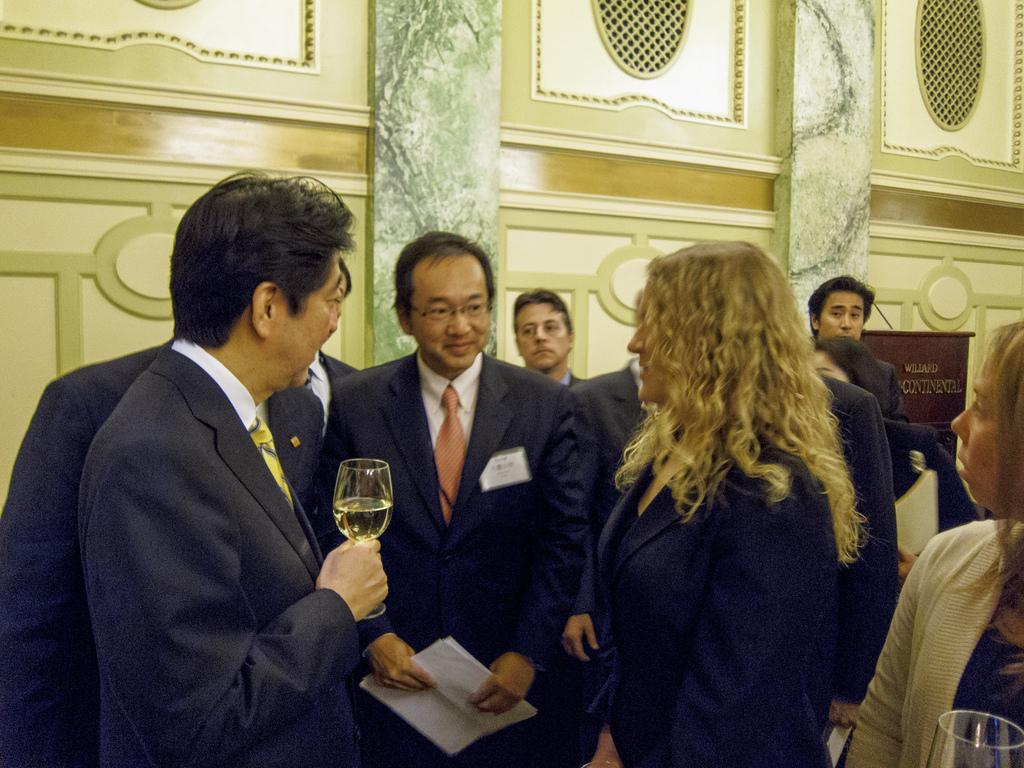How many people are in the image? There is a group of people in the image. What are some of the people holding? Some of the people are holding glasses. What is the man holding in the image? One man is holding papers. What can be seen in the background of the image? There is a wall in the background of the image. What type of spot can be seen on the authority figure in the image? There is no authority figure present in the image, and therefore no spot can be observed. 